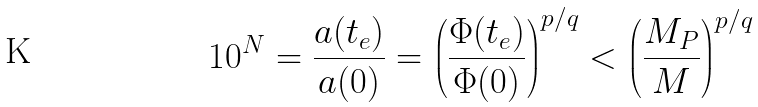Convert formula to latex. <formula><loc_0><loc_0><loc_500><loc_500>1 0 ^ { N } = \frac { a ( t _ { e } ) } { a ( 0 ) } = \left ( \frac { \Phi ( t _ { e } ) } { \Phi ( 0 ) } \right ) ^ { p / q } < \left ( \frac { M _ { P } } { M } \right ) ^ { p / q }</formula> 